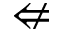<formula> <loc_0><loc_0><loc_500><loc_500>\ n L e f t a r r o w</formula> 